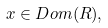Convert formula to latex. <formula><loc_0><loc_0><loc_500><loc_500>x \in D o m ( R ) ,</formula> 